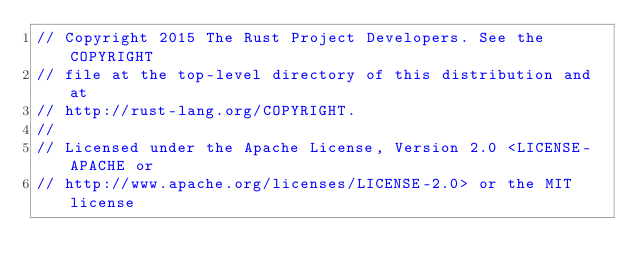<code> <loc_0><loc_0><loc_500><loc_500><_Rust_>// Copyright 2015 The Rust Project Developers. See the COPYRIGHT
// file at the top-level directory of this distribution and at
// http://rust-lang.org/COPYRIGHT.
//
// Licensed under the Apache License, Version 2.0 <LICENSE-APACHE or
// http://www.apache.org/licenses/LICENSE-2.0> or the MIT license</code> 